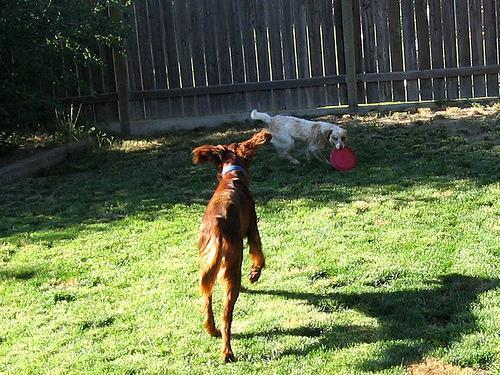How many dogs are in the picture?
Give a very brief answer. 2. 